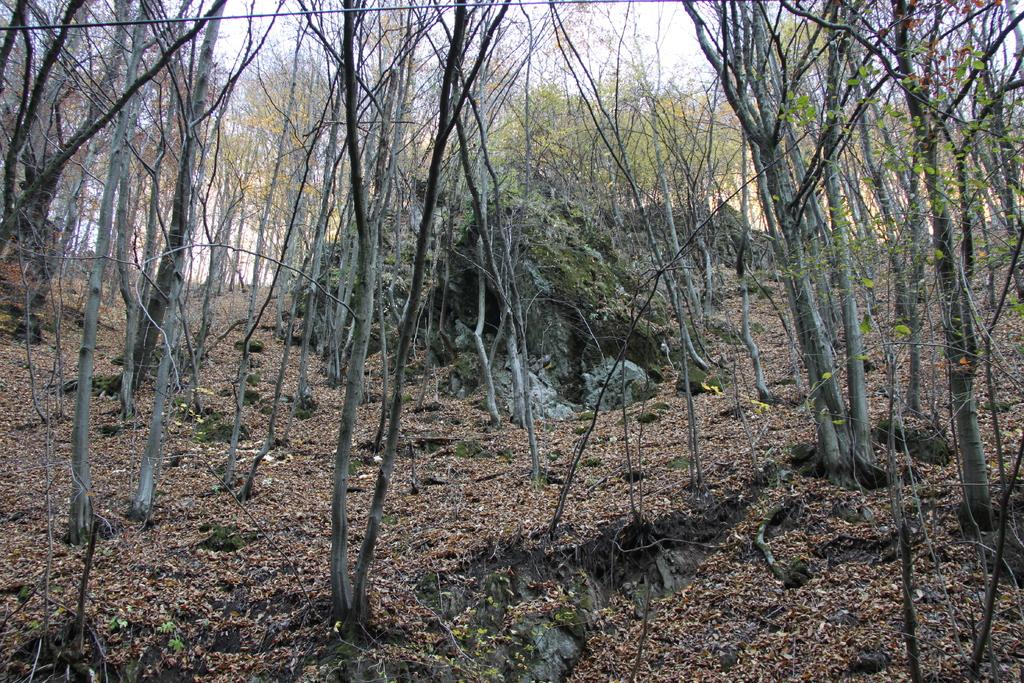What type of vegetation can be seen in the image? There are many trees in the image. What is on the ground beneath the trees? There are dry leaves on the ground in the image. What is visible above the trees? There is a sky visible in the image. Can you see any fangs on the trees in the image? There are no fangs present on the trees in the image; they are simply trees with no animal or creature features. 